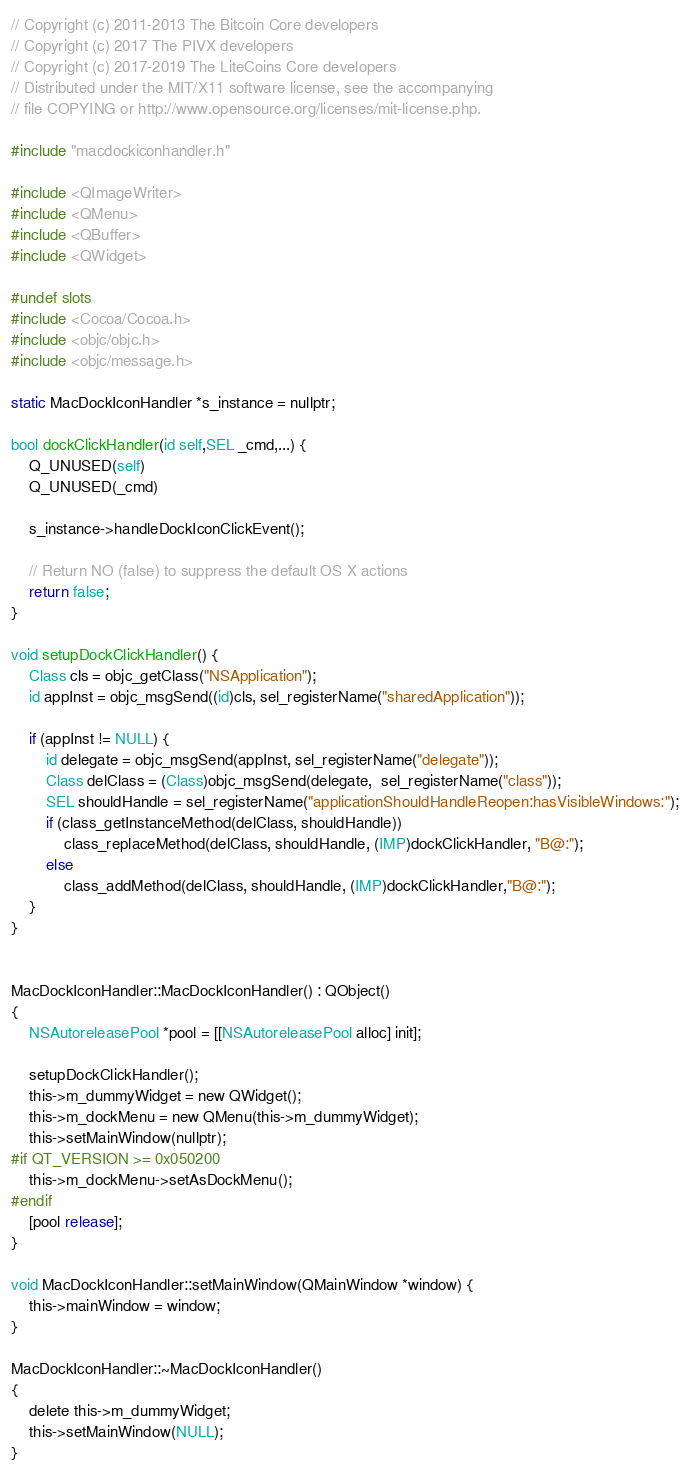<code> <loc_0><loc_0><loc_500><loc_500><_ObjectiveC_>// Copyright (c) 2011-2013 The Bitcoin Core developers
// Copyright (c) 2017 The PIVX developers
// Copyright (c) 2017-2019 The LiteCoins Core developers
// Distributed under the MIT/X11 software license, see the accompanying
// file COPYING or http://www.opensource.org/licenses/mit-license.php.

#include "macdockiconhandler.h"

#include <QImageWriter>
#include <QMenu>
#include <QBuffer>
#include <QWidget>

#undef slots
#include <Cocoa/Cocoa.h>
#include <objc/objc.h>
#include <objc/message.h>

static MacDockIconHandler *s_instance = nullptr;

bool dockClickHandler(id self,SEL _cmd,...) {
    Q_UNUSED(self)
    Q_UNUSED(_cmd)

    s_instance->handleDockIconClickEvent();

    // Return NO (false) to suppress the default OS X actions
    return false;
}

void setupDockClickHandler() {
    Class cls = objc_getClass("NSApplication");
    id appInst = objc_msgSend((id)cls, sel_registerName("sharedApplication"));

    if (appInst != NULL) {
        id delegate = objc_msgSend(appInst, sel_registerName("delegate"));
        Class delClass = (Class)objc_msgSend(delegate,  sel_registerName("class"));
        SEL shouldHandle = sel_registerName("applicationShouldHandleReopen:hasVisibleWindows:");
        if (class_getInstanceMethod(delClass, shouldHandle))
            class_replaceMethod(delClass, shouldHandle, (IMP)dockClickHandler, "B@:");
        else
            class_addMethod(delClass, shouldHandle, (IMP)dockClickHandler,"B@:");
    }
}


MacDockIconHandler::MacDockIconHandler() : QObject()
{
    NSAutoreleasePool *pool = [[NSAutoreleasePool alloc] init];

    setupDockClickHandler();
    this->m_dummyWidget = new QWidget();
    this->m_dockMenu = new QMenu(this->m_dummyWidget);
    this->setMainWindow(nullptr);
#if QT_VERSION >= 0x050200
    this->m_dockMenu->setAsDockMenu();
#endif
    [pool release];
}

void MacDockIconHandler::setMainWindow(QMainWindow *window) {
    this->mainWindow = window;
}

MacDockIconHandler::~MacDockIconHandler()
{
    delete this->m_dummyWidget;
    this->setMainWindow(NULL);
}
</code> 